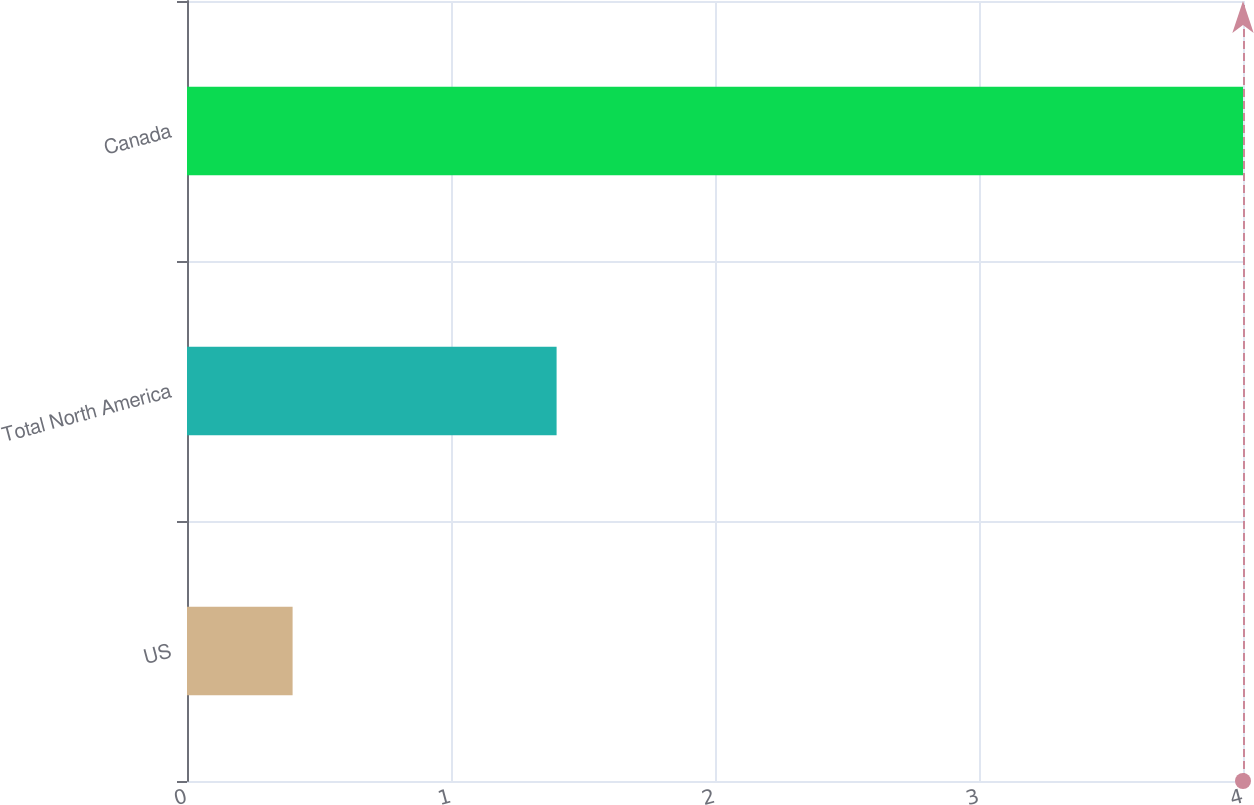<chart> <loc_0><loc_0><loc_500><loc_500><bar_chart><fcel>US<fcel>Total North America<fcel>Canada<nl><fcel>0.4<fcel>1.4<fcel>4<nl></chart> 